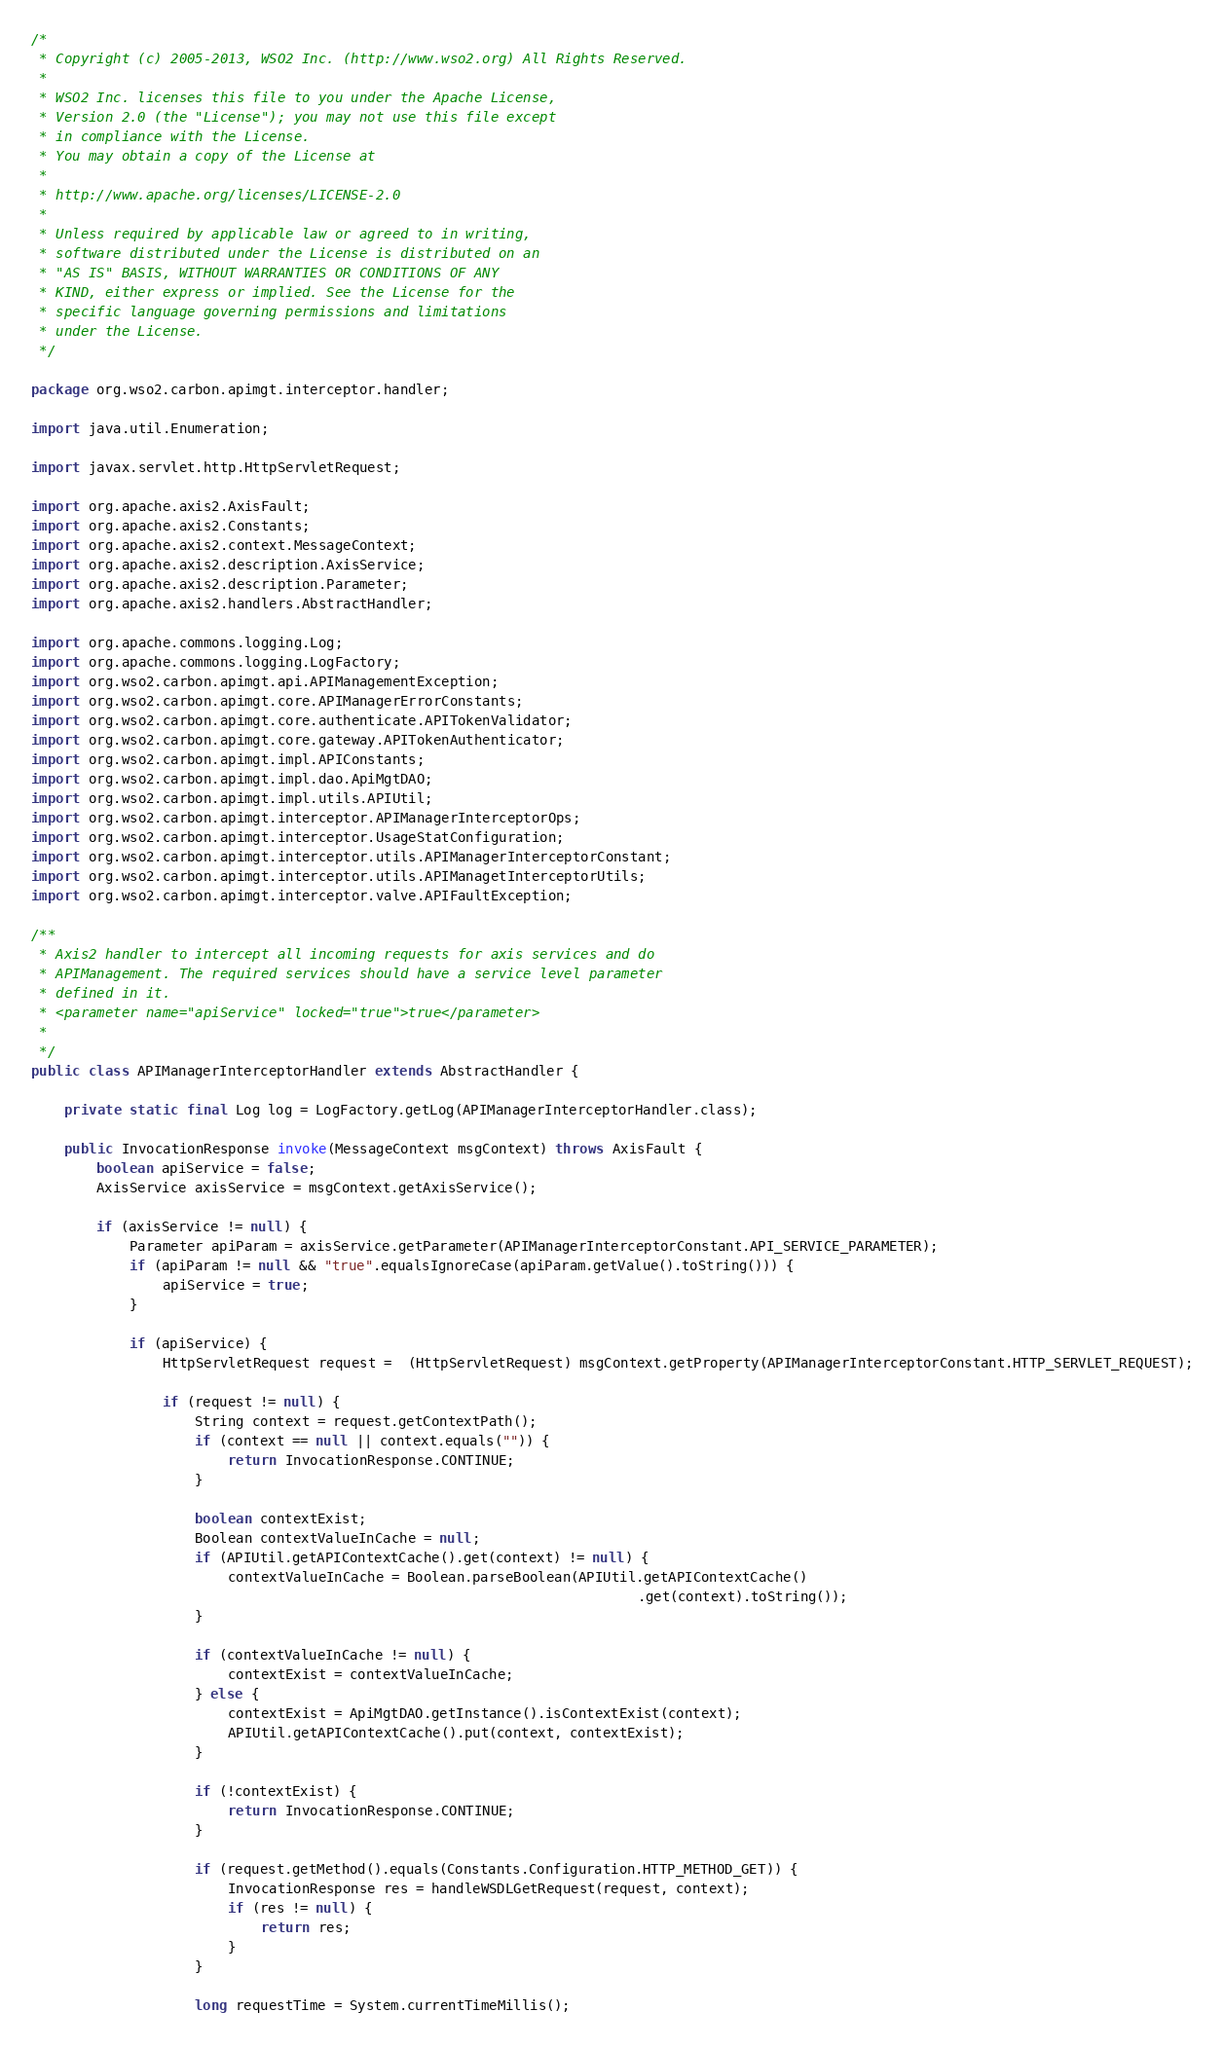<code> <loc_0><loc_0><loc_500><loc_500><_Java_>/*
 * Copyright (c) 2005-2013, WSO2 Inc. (http://www.wso2.org) All Rights Reserved.
 * 
 * WSO2 Inc. licenses this file to you under the Apache License,
 * Version 2.0 (the "License"); you may not use this file except
 * in compliance with the License.
 * You may obtain a copy of the License at
 * 
 * http://www.apache.org/licenses/LICENSE-2.0
 * 
 * Unless required by applicable law or agreed to in writing,
 * software distributed under the License is distributed on an
 * "AS IS" BASIS, WITHOUT WARRANTIES OR CONDITIONS OF ANY
 * KIND, either express or implied. See the License for the
 * specific language governing permissions and limitations
 * under the License.
 */

package org.wso2.carbon.apimgt.interceptor.handler;

import java.util.Enumeration;

import javax.servlet.http.HttpServletRequest;

import org.apache.axis2.AxisFault;
import org.apache.axis2.Constants;
import org.apache.axis2.context.MessageContext;
import org.apache.axis2.description.AxisService;
import org.apache.axis2.description.Parameter;
import org.apache.axis2.handlers.AbstractHandler;

import org.apache.commons.logging.Log;
import org.apache.commons.logging.LogFactory;
import org.wso2.carbon.apimgt.api.APIManagementException;
import org.wso2.carbon.apimgt.core.APIManagerErrorConstants;
import org.wso2.carbon.apimgt.core.authenticate.APITokenValidator;
import org.wso2.carbon.apimgt.core.gateway.APITokenAuthenticator;
import org.wso2.carbon.apimgt.impl.APIConstants;
import org.wso2.carbon.apimgt.impl.dao.ApiMgtDAO;
import org.wso2.carbon.apimgt.impl.utils.APIUtil;
import org.wso2.carbon.apimgt.interceptor.APIManagerInterceptorOps;
import org.wso2.carbon.apimgt.interceptor.UsageStatConfiguration;
import org.wso2.carbon.apimgt.interceptor.utils.APIManagerInterceptorConstant;
import org.wso2.carbon.apimgt.interceptor.utils.APIManagetInterceptorUtils;
import org.wso2.carbon.apimgt.interceptor.valve.APIFaultException;

/**
 * Axis2 handler to intercept all incoming requests for axis services and do
 * APIManagement. The required services should have a service level parameter
 * defined in it.
 * <parameter name="apiService" locked="true">true</parameter>
 * 
 */
public class APIManagerInterceptorHandler extends AbstractHandler {

	private static final Log log = LogFactory.getLog(APIManagerInterceptorHandler.class);
	
	public InvocationResponse invoke(MessageContext msgContext) throws AxisFault {
		boolean apiService = false;
		AxisService axisService = msgContext.getAxisService();

		if (axisService != null) {
			Parameter apiParam = axisService.getParameter(APIManagerInterceptorConstant.API_SERVICE_PARAMETER);
			if (apiParam != null && "true".equalsIgnoreCase(apiParam.getValue().toString())) {
				apiService = true;
			}

			if (apiService) {
				HttpServletRequest request =  (HttpServletRequest) msgContext.getProperty(APIManagerInterceptorConstant.HTTP_SERVLET_REQUEST);

				if (request != null) {
					String context = request.getContextPath();					
					if (context == null || context.equals("")) {
						return InvocationResponse.CONTINUE;
					}

					boolean contextExist;
					Boolean contextValueInCache = null;
					if (APIUtil.getAPIContextCache().get(context) != null) {
						contextValueInCache = Boolean.parseBoolean(APIUtil.getAPIContextCache()
						                                                  .get(context).toString());
					}

					if (contextValueInCache != null) {
						contextExist = contextValueInCache;
					} else {
						contextExist = ApiMgtDAO.getInstance().isContextExist(context);
						APIUtil.getAPIContextCache().put(context, contextExist);
					}

					if (!contextExist) {
						return InvocationResponse.CONTINUE;
					}

					if (request.getMethod().equals(Constants.Configuration.HTTP_METHOD_GET)) {
						InvocationResponse res = handleWSDLGetRequest(request, context);
						if (res != null) {
							return res;
						}
					}

					long requestTime = System.currentTimeMillis();</code> 